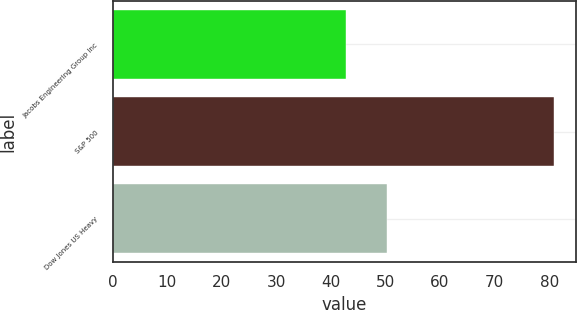<chart> <loc_0><loc_0><loc_500><loc_500><bar_chart><fcel>Jacobs Engineering Group Inc<fcel>S&P 500<fcel>Dow Jones US Heavy<nl><fcel>42.72<fcel>80.93<fcel>50.23<nl></chart> 